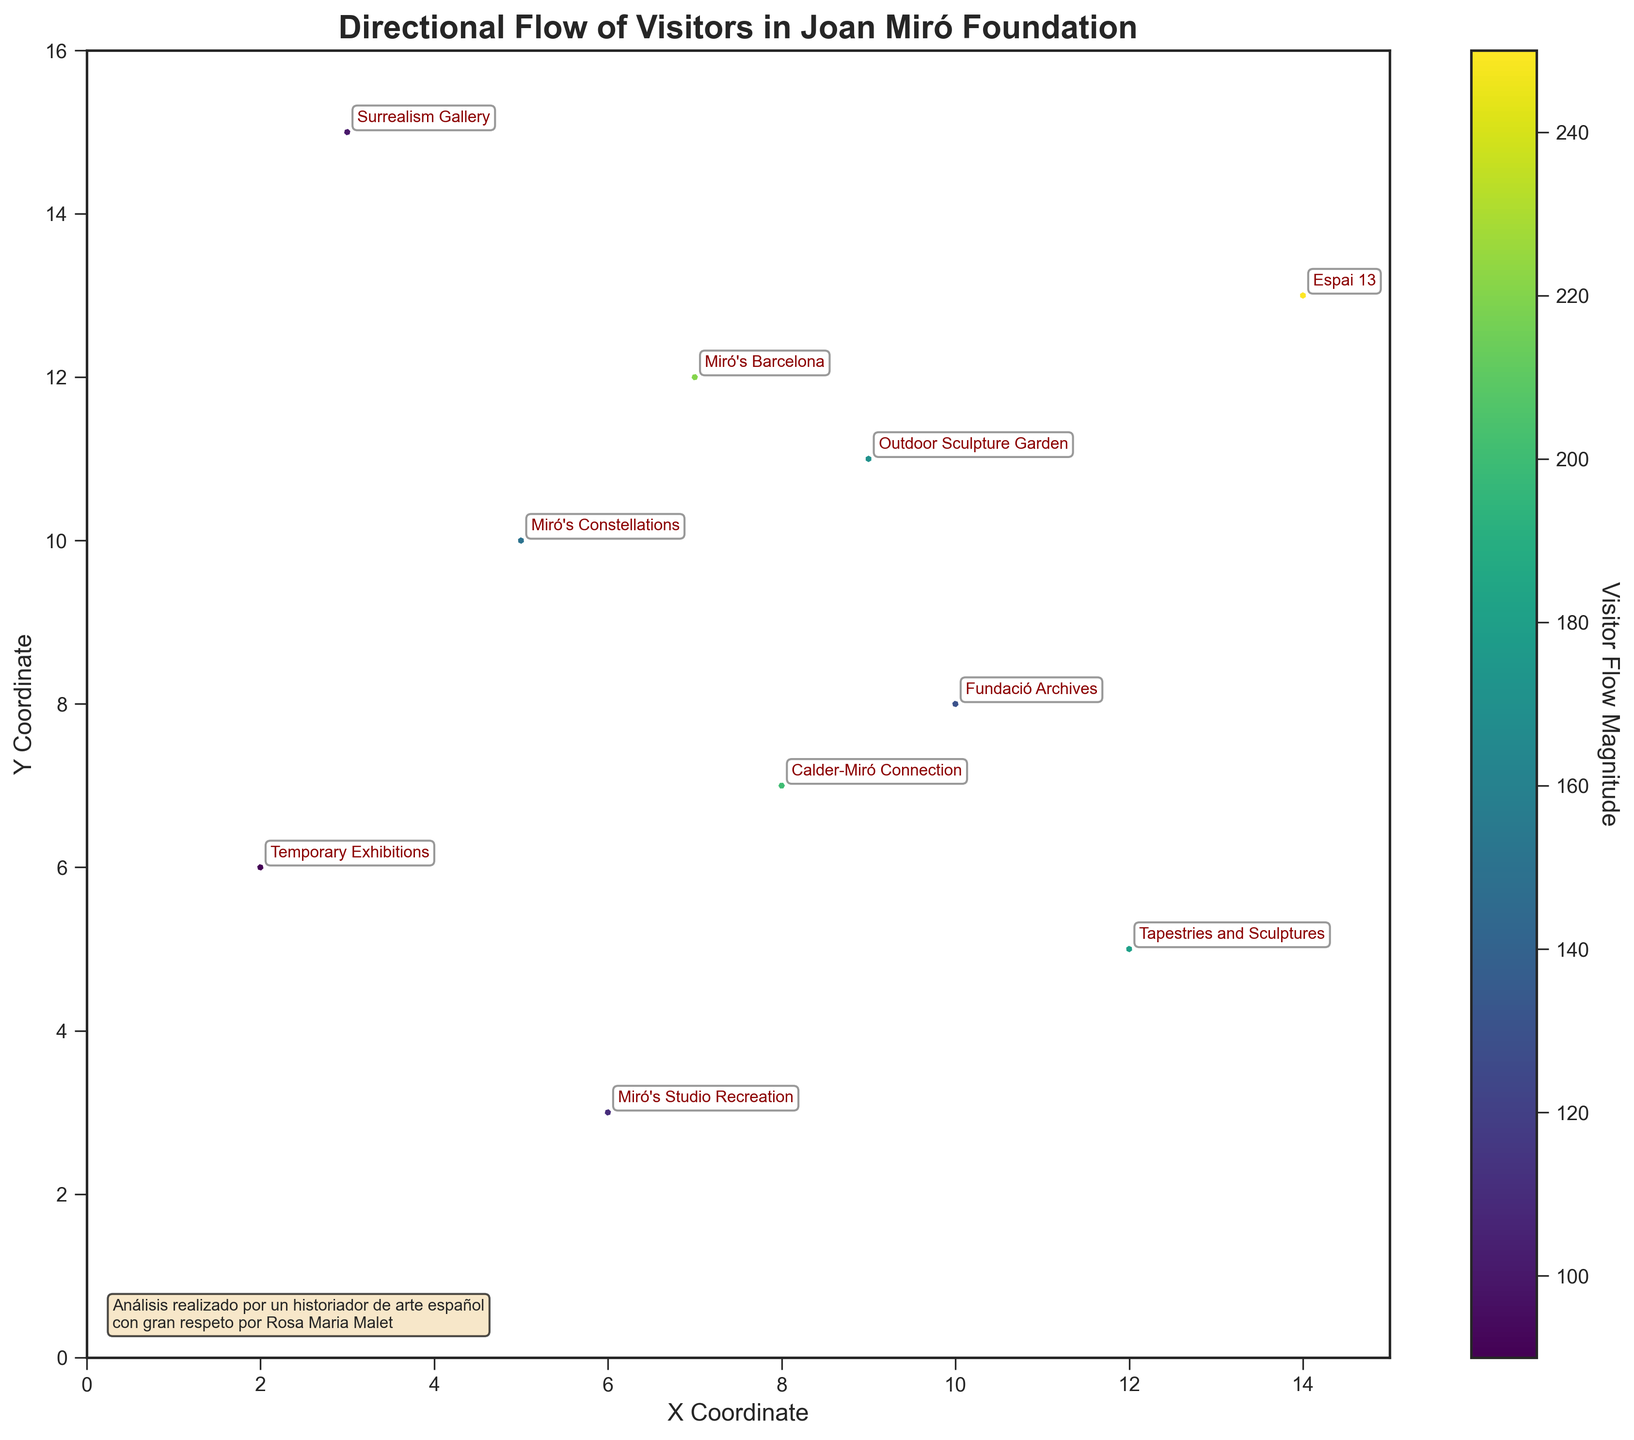What is the title of the plot? The title of the plot is written at the top of the figure. It states the main subject of the plot.
Answer: Directional Flow of Visitors in Joan Miró Foundation How many exhibitions are depicted on the plot? By looking at the labels annotated near the arrows, we can count the number of exhibitions shown on the plot.
Answer: 10 Which exhibition has the highest visitor flow magnitude? The color intensity of the arrows represents the magnitude of visitor flow. The darker the color, the higher the magnitude. We identify the darkest colored arrow and read the corresponding annotation to find the exhibition.
Answer: Espai 13 What are the general directions of visitor movement from "Miró's Constellations" and "Fundació Archives"? We need to look at the directions of the arrows originating from "Miró's Constellations" and "Fundació Archives" and describe their direction vectors.
Answer: From "Miró's Constellations": right and slightly downward, From "Fundació Archives": left and slightly downward How does the visitor flow from "Tapestries and Sculptures" compare to that from "Calder-Miró Connection"? We compare the visitor flow magnitudes by checking the colors of the arrows and referring to their annotated magnitudes.
Answer: "Tapestries and Sculptures" has lower flow magnitude (180) compared to "Calder-Miró Connection" (200) What are the coordinates of "Miró's Studio Recreation" on the plot? We identify the label "Miró's Studio Recreation" on the plot and note its position on the x and y axes.
Answer: (6, 3) Which direction is the visitor movement from "Outdoor Sculpture Garden"? We look at the direction vector of the arrow originating from "Outdoor Sculpture Garden" (using the x and y components).
Answer: Upward Calculate the average magnitude of visitor flow in exhibitions "Miró's Barcelona" and "Temporary Exhibitions". We sum up the magnitudes of visitor flow for "Miró's Barcelona" (220) and "Temporary Exhibitions" (90) and then find the average. \( \text{Average} = \frac{220 + 90}{2} \).
Answer: 155 Which exhibition has the most visitors flowing downward? We observe the direction of the y-component of the arrows; a negative y-component indicates downward movement. We then identify which exhibition has the maximum magnitude among them.
Answer: Calder-Miró Connection Describe the visitor flow between "Miró's Constellations" and "Tapestries and Sculptures"? We examine the arrows connecting these exhibitions and indicate both the vectors' components and flow magnitude. "Miró's Constellations": (2, -1) magnitude 150, "Tapestries and Sculptures": (-2, 1) magnitude 180.
Answer: Miró's Constellations to right and slightly downward, Tapestries and Sculptures to left and slightly upward 